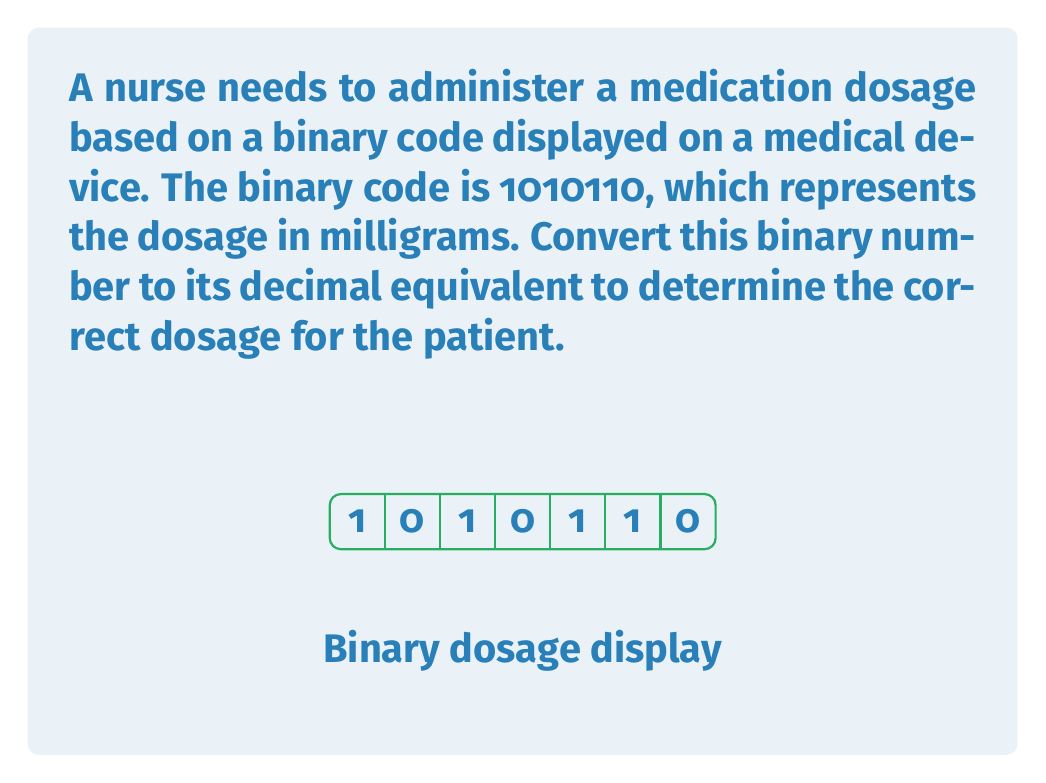Could you help me with this problem? To convert a binary number to decimal, we need to multiply each digit by its corresponding power of 2 and sum the results. The rightmost digit corresponds to $2^0$, the next to $2^1$, and so on.

Let's break down the conversion step-by-step:

1) The binary number is 1010110 (reading from left to right).
2) We assign powers of 2 to each digit, starting from the right:

   $$1 \cdot 2^6 + 0 \cdot 2^5 + 1 \cdot 2^4 + 0 \cdot 2^3 + 1 \cdot 2^2 + 1 \cdot 2^1 + 0 \cdot 2^0$$

3) Now, let's calculate each term:
   
   $$1 \cdot 64 + 0 \cdot 32 + 1 \cdot 16 + 0 \cdot 8 + 1 \cdot 4 + 1 \cdot 2 + 0 \cdot 1$$

4) Simplifying:

   $$64 + 0 + 16 + 0 + 4 + 2 + 0$$

5) Adding these numbers:

   $$64 + 16 + 4 + 2 = 86$$

Therefore, the binary number 1010110 is equivalent to the decimal number 86.
Answer: 86 mg 